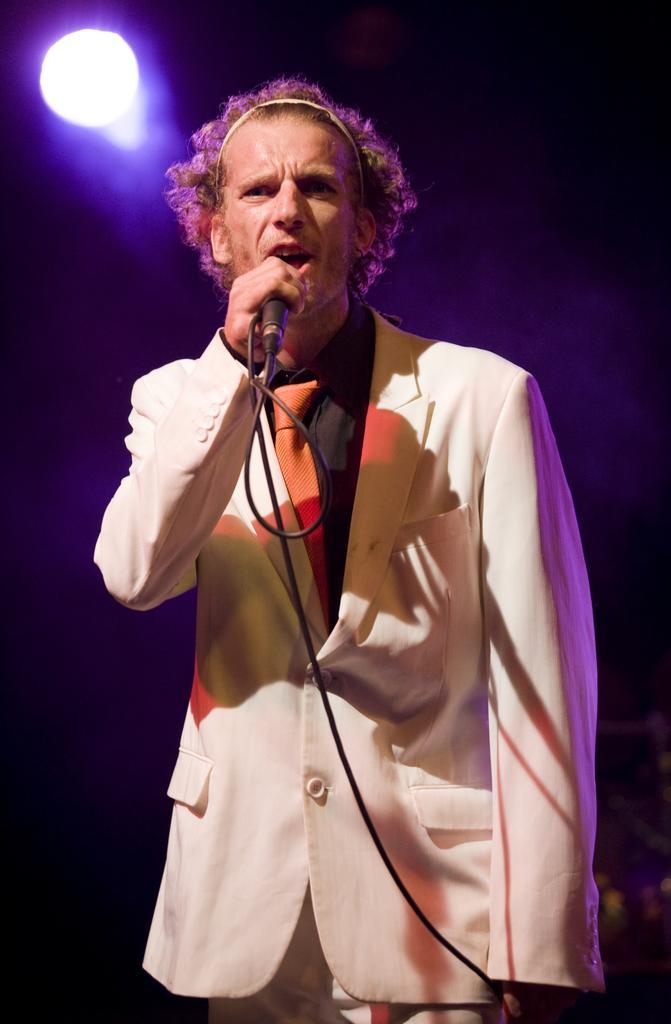Can you describe this image briefly? This man is standing and holding a mic. This man wore white suit and tie. At the top of the picture there is a light. 